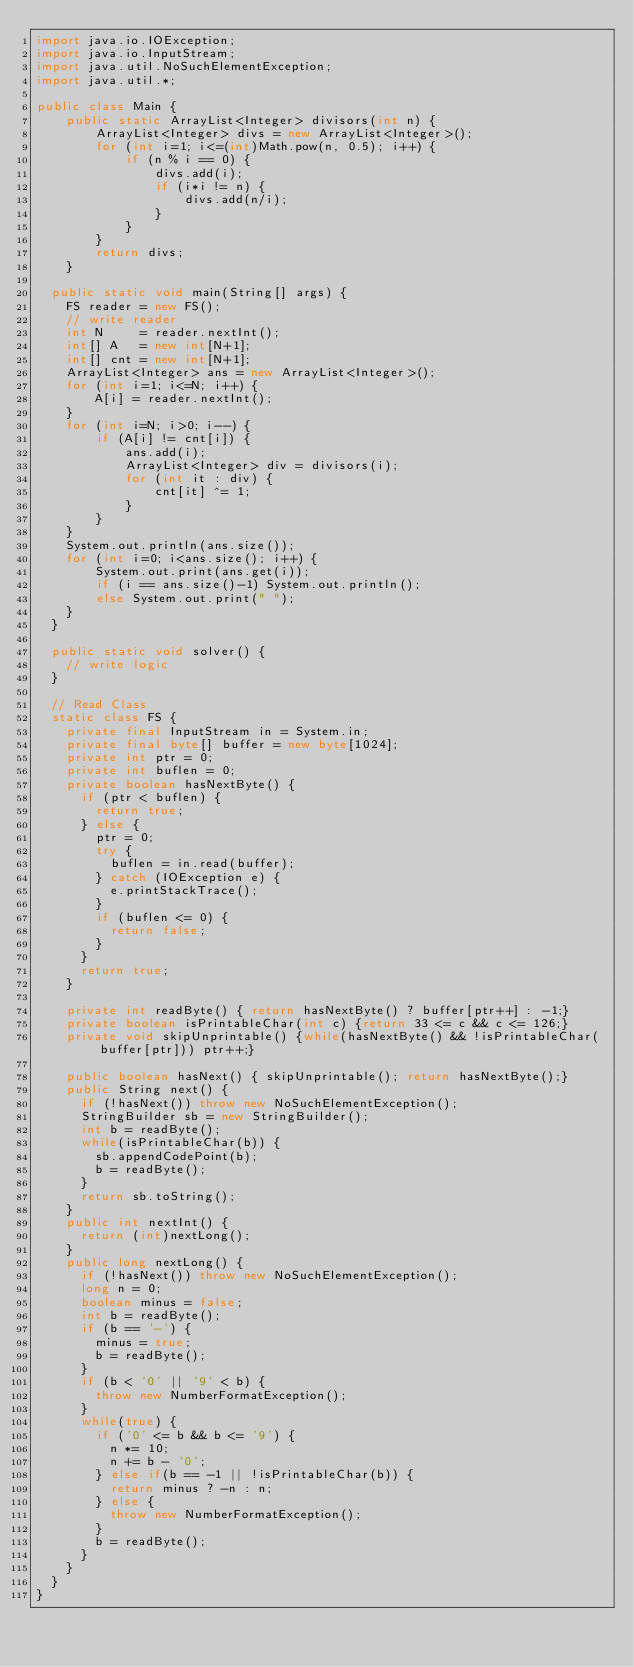<code> <loc_0><loc_0><loc_500><loc_500><_Java_>import java.io.IOException;
import java.io.InputStream;
import java.util.NoSuchElementException;
import java.util.*;

public class Main {
    public static ArrayList<Integer> divisors(int n) {
        ArrayList<Integer> divs = new ArrayList<Integer>();
        for (int i=1; i<=(int)Math.pow(n, 0.5); i++) {
            if (n % i == 0) {
                divs.add(i);
                if (i*i != n) {
                    divs.add(n/i);
                }
            }
        }
        return divs;
    }

	public static void main(String[] args) {
		FS reader = new FS();
		// write reader
		int N     = reader.nextInt();
		int[] A   = new int[N+1];
		int[] cnt = new int[N+1];
		ArrayList<Integer> ans = new ArrayList<Integer>();
		for (int i=1; i<=N; i++) {
		    A[i] = reader.nextInt();
		}
		for (int i=N; i>0; i--) {
		    if (A[i] != cnt[i]) {
		        ans.add(i);
		        ArrayList<Integer> div = divisors(i);
		        for (int it : div) {
		            cnt[it] ^= 1;
		        }
		    }
		}
		System.out.println(ans.size());
		for (int i=0; i<ans.size(); i++) {
		    System.out.print(ans.get(i));
		    if (i == ans.size()-1) System.out.println();
		    else System.out.print(" ");
		}
	}
	
	public static void solver() {
		// write logic
	}
	
	// Read Class
	static class FS {
		private final InputStream in = System.in;
		private final byte[] buffer = new byte[1024];
		private int ptr = 0;
		private int buflen = 0;
		private boolean hasNextByte() {
			if (ptr < buflen) {
				return true;
			} else {
				ptr = 0;
				try {
					buflen = in.read(buffer);
				} catch (IOException e) {
					e.printStackTrace();
				}
				if (buflen <= 0) {
					return false;
				}
			}
			return true;
		}
	
		private int readByte() { return hasNextByte() ? buffer[ptr++] : -1;}
		private boolean isPrintableChar(int c) {return 33 <= c && c <= 126;}
		private void skipUnprintable() {while(hasNextByte() && !isPrintableChar(buffer[ptr])) ptr++;}
	
		public boolean hasNext() { skipUnprintable(); return hasNextByte();}
		public String next() {
			if (!hasNext()) throw new NoSuchElementException();
			StringBuilder sb = new StringBuilder();
			int b = readByte();
			while(isPrintableChar(b)) {
				sb.appendCodePoint(b);
				b = readByte();
			}
			return sb.toString();
		}
		public int nextInt() {
			return (int)nextLong();
		}
		public long nextLong() {
			if (!hasNext()) throw new NoSuchElementException();
			long n = 0;
			boolean minus = false;
			int b = readByte();
			if (b == '-') {
				minus = true;
				b = readByte();
			}
			if (b < '0' || '9' < b) {
				throw new NumberFormatException();
			}
			while(true) {
				if ('0' <= b && b <= '9') {
					n *= 10;
					n += b - '0';
				} else if(b == -1 || !isPrintableChar(b)) {
					return minus ? -n : n;
				} else {
					throw new NumberFormatException();
				}
				b = readByte();
			}
		}
	}
}
</code> 